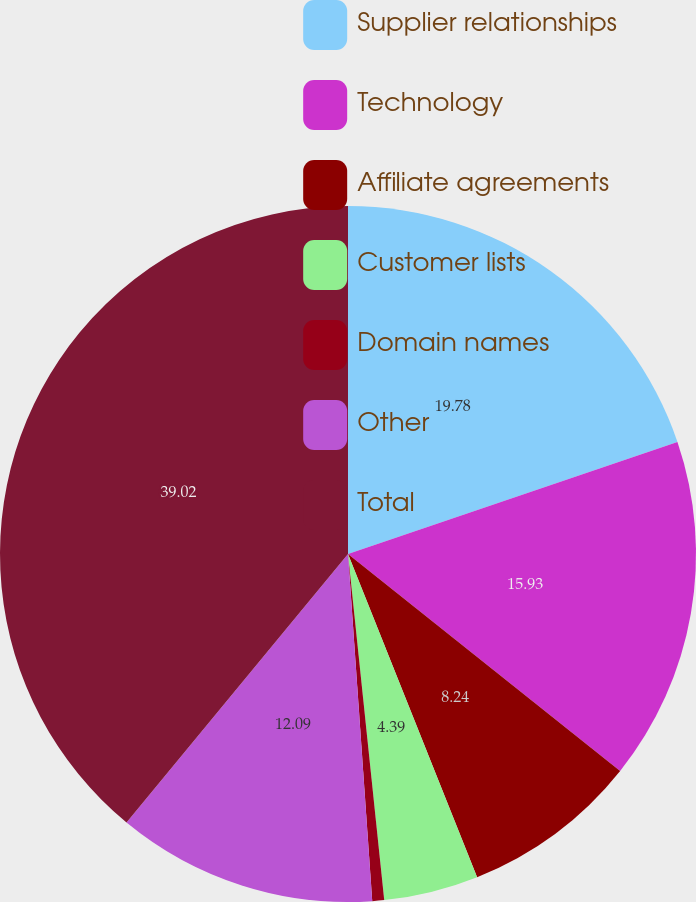Convert chart to OTSL. <chart><loc_0><loc_0><loc_500><loc_500><pie_chart><fcel>Supplier relationships<fcel>Technology<fcel>Affiliate agreements<fcel>Customer lists<fcel>Domain names<fcel>Other<fcel>Total<nl><fcel>19.78%<fcel>15.93%<fcel>8.24%<fcel>4.39%<fcel>0.55%<fcel>12.09%<fcel>39.02%<nl></chart> 